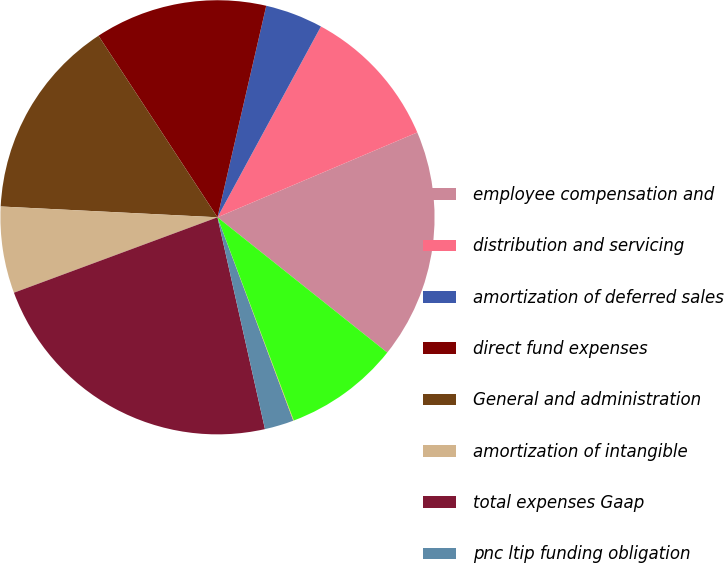Convert chart to OTSL. <chart><loc_0><loc_0><loc_500><loc_500><pie_chart><fcel>employee compensation and<fcel>distribution and servicing<fcel>amortization of deferred sales<fcel>direct fund expenses<fcel>General and administration<fcel>amortization of intangible<fcel>total expenses Gaap<fcel>pnc ltip funding obligation<fcel>Merrill lynch compensation<fcel>total non-Gaap expense<nl><fcel>17.1%<fcel>10.7%<fcel>4.3%<fcel>12.84%<fcel>14.97%<fcel>6.44%<fcel>22.86%<fcel>2.17%<fcel>0.04%<fcel>8.57%<nl></chart> 